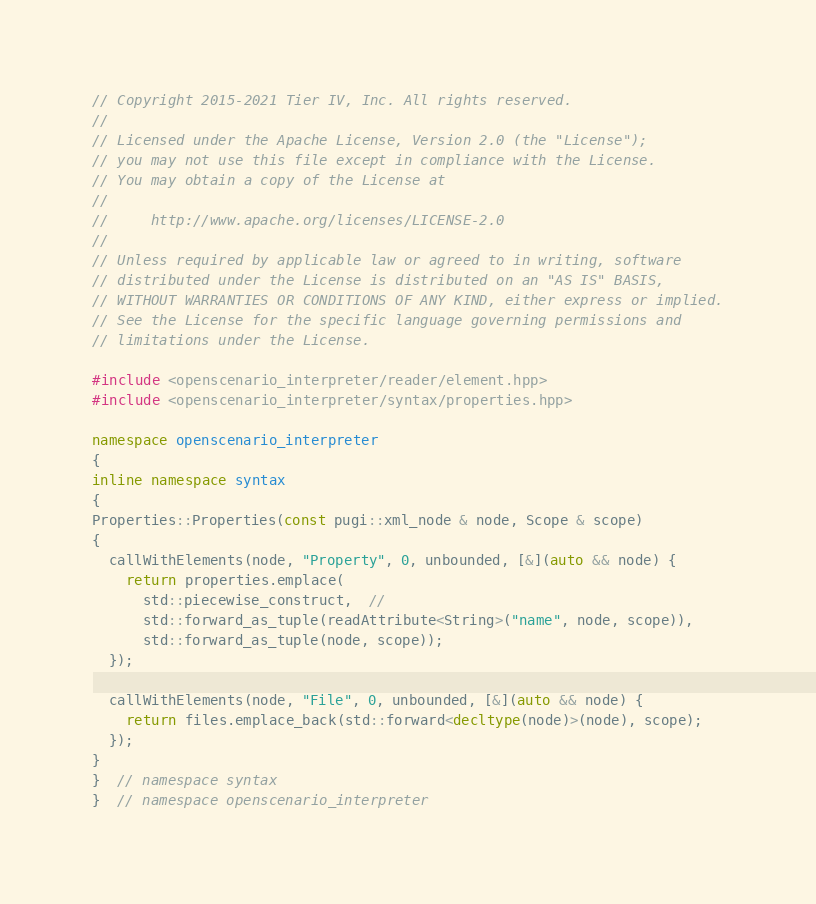<code> <loc_0><loc_0><loc_500><loc_500><_C++_>// Copyright 2015-2021 Tier IV, Inc. All rights reserved.
//
// Licensed under the Apache License, Version 2.0 (the "License");
// you may not use this file except in compliance with the License.
// You may obtain a copy of the License at
//
//     http://www.apache.org/licenses/LICENSE-2.0
//
// Unless required by applicable law or agreed to in writing, software
// distributed under the License is distributed on an "AS IS" BASIS,
// WITHOUT WARRANTIES OR CONDITIONS OF ANY KIND, either express or implied.
// See the License for the specific language governing permissions and
// limitations under the License.

#include <openscenario_interpreter/reader/element.hpp>
#include <openscenario_interpreter/syntax/properties.hpp>

namespace openscenario_interpreter
{
inline namespace syntax
{
Properties::Properties(const pugi::xml_node & node, Scope & scope)
{
  callWithElements(node, "Property", 0, unbounded, [&](auto && node) {
    return properties.emplace(
      std::piecewise_construct,  //
      std::forward_as_tuple(readAttribute<String>("name", node, scope)),
      std::forward_as_tuple(node, scope));
  });

  callWithElements(node, "File", 0, unbounded, [&](auto && node) {
    return files.emplace_back(std::forward<decltype(node)>(node), scope);
  });
}
}  // namespace syntax
}  // namespace openscenario_interpreter
</code> 